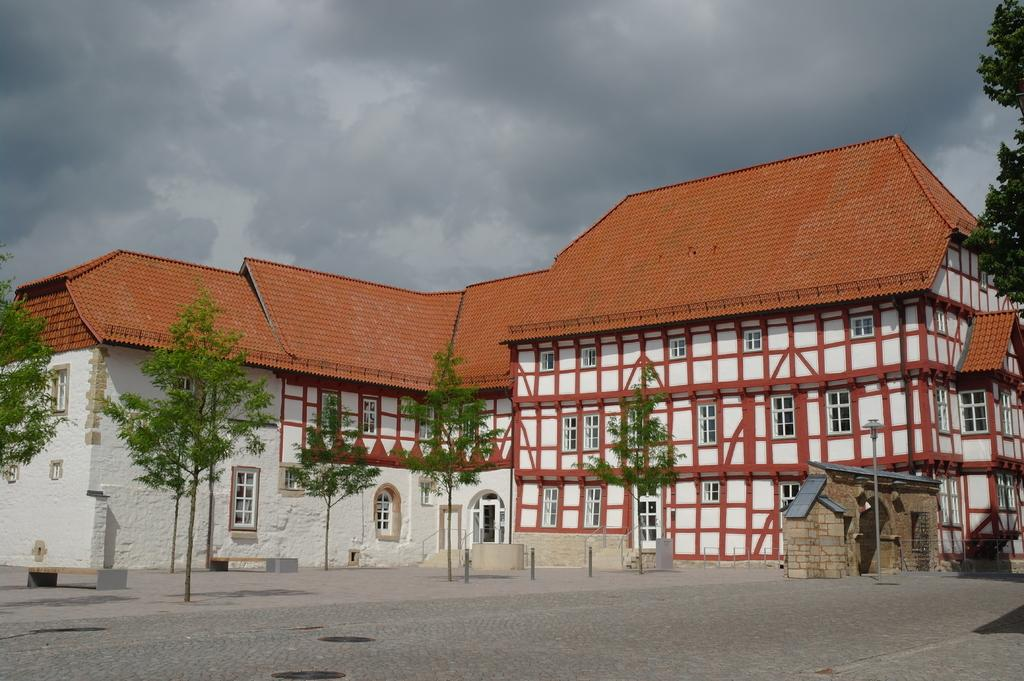What type of structure is present in the image? There is a building in the image. What can be seen on the road in the image? There are trees on the road in the image. Where are the cubs playing with the bucket in the image? There are no cubs or buckets present in the image. What type of flowers can be seen growing near the building in the image? There is no mention of flowers in the image; only a building and trees on the road are present. 